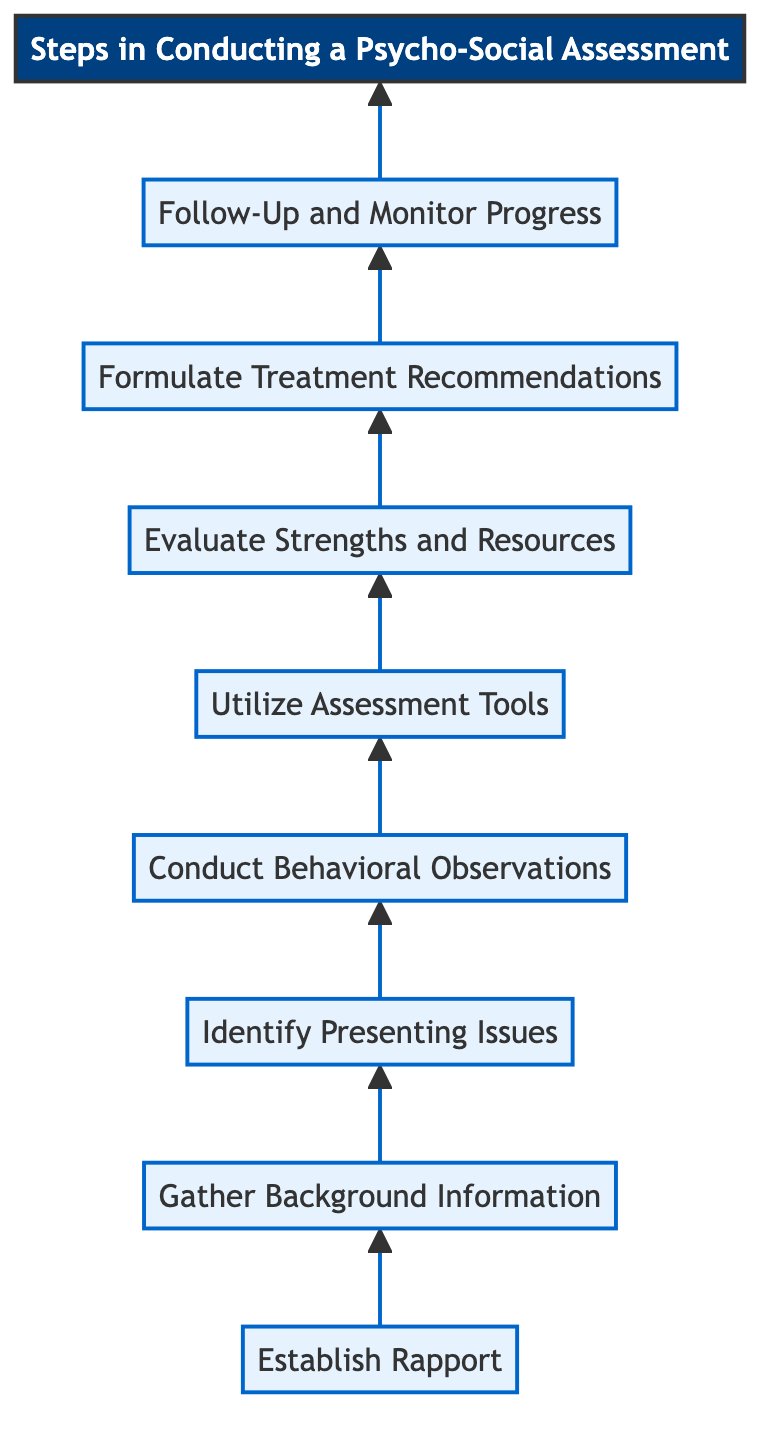What is the first step in conducting a psycho-social assessment? The first step is represented at the top of the flowchart and is titled "Establish Rapport". This step comes before all others, indicating it is the starting point of the process.
Answer: Establish Rapport How many total steps are there in the flowchart? By counting each individual step in the flowchart, including "Establish Rapport" down to "Follow-Up and Monitor Progress," we find there are eight distinct steps.
Answer: Eight Which step follows "Conduct Behavioral Observations"? In the flowchart, the step that directly follows "Conduct Behavioral Observations" is "Utilize Assessment Tools," as indicated by the arrow connecting these two nodes.
Answer: Utilize Assessment Tools What is the last step outlined in the flowchart? The last step in the flowchart, positioned above the title node, is "Follow-Up and Monitor Progress," showing it is the final action taken in the assessment process.
Answer: Follow-Up and Monitor Progress How are the steps connected in the flowchart? The steps in the flowchart are connected in a linear fashion, where each step leads to the next in sequence, with arrows showing the direction of flow from one step to the other.
Answer: Linear connection Which step comes after "Evaluate Strengths and Resources"? By examining the flowchart's sequence, the step that follows "Evaluate Strengths and Resources" is "Formulate Treatment Recommendations," indicating the progression from evaluation to planning.
Answer: Formulate Treatment Recommendations What is the primary goal of the first step? The primary goal of "Establish Rapport" is to create a safe and trusting environment for the client, which is essential for the success of the subsequent assessments and interventions.
Answer: Create a safe and trusting environment In terms of flow, what does the arrow direction signify? The direction of the arrows in the flowchart signifies the order in which the steps should be performed, showing a clear path from starting to ending points of the psycho-social assessment process.
Answer: Order of steps 